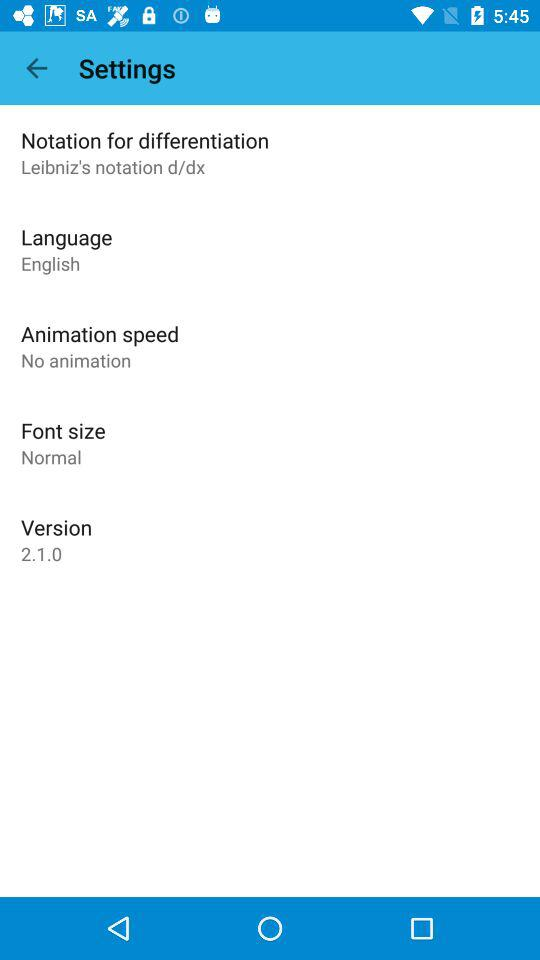What's the "Animation speed"? "Animation speed" is set to "No animation". 